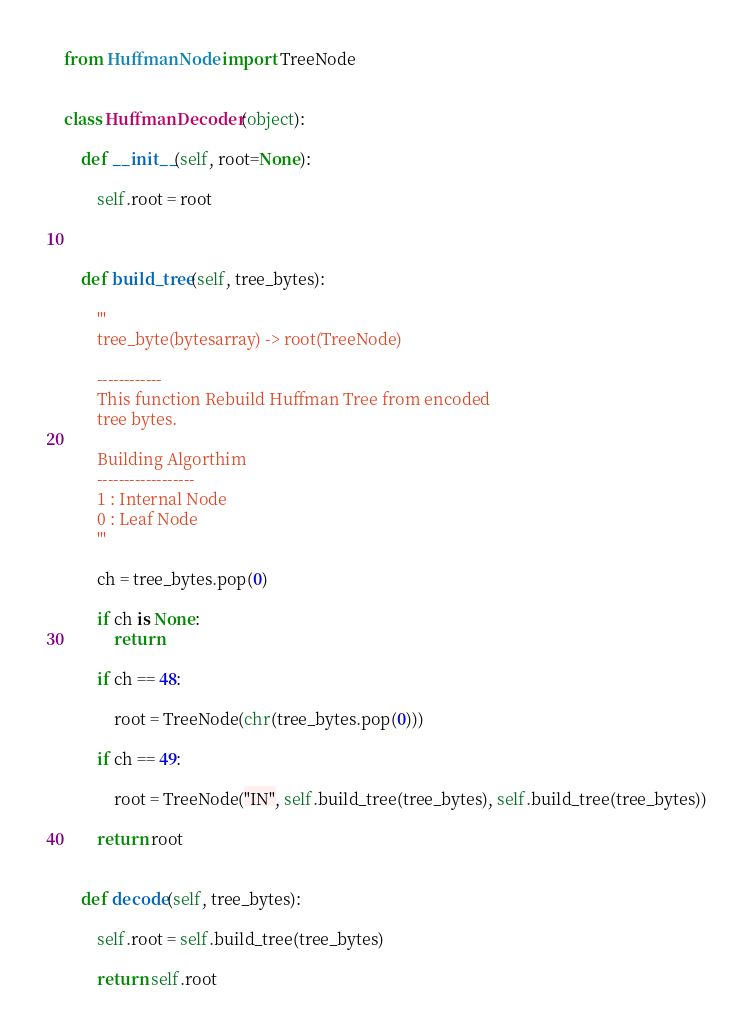<code> <loc_0><loc_0><loc_500><loc_500><_Python_>from HuffmanNode import TreeNode


class HuffmanDecoder(object):

	def __init__(self, root=None):

		self.root = root



	def build_tree(self, tree_bytes):

		'''
		tree_byte(bytesarray) -> root(TreeNode)

		------------
		This function Rebuild Huffman Tree from encoded 
		tree bytes.

		Building Algorthim
		------------------
		1 : Internal Node 
		0 : Leaf Node
		'''

		ch = tree_bytes.pop(0)

		if ch is None:
			return

		if ch == 48:
 
 			root = TreeNode(chr(tree_bytes.pop(0)))

		if ch == 49:

			root = TreeNode("IN", self.build_tree(tree_bytes), self.build_tree(tree_bytes))

		return root


	def decode(self, tree_bytes):

		self.root = self.build_tree(tree_bytes)

		return self.root</code> 